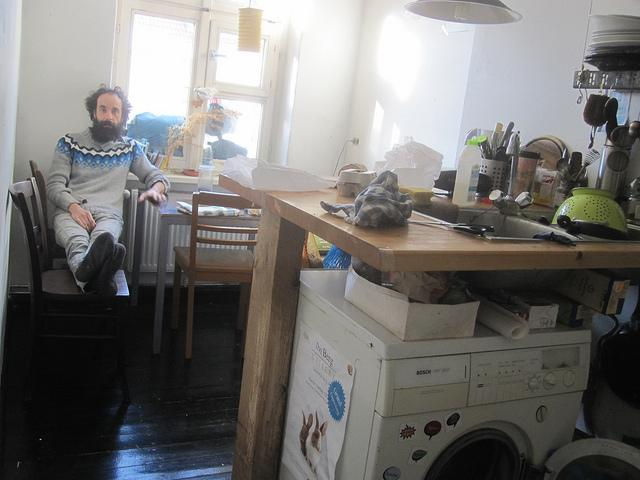What is the green object with holes in it called? Please explain your reasoning. colander. Colanders have holes in them to strain food. 